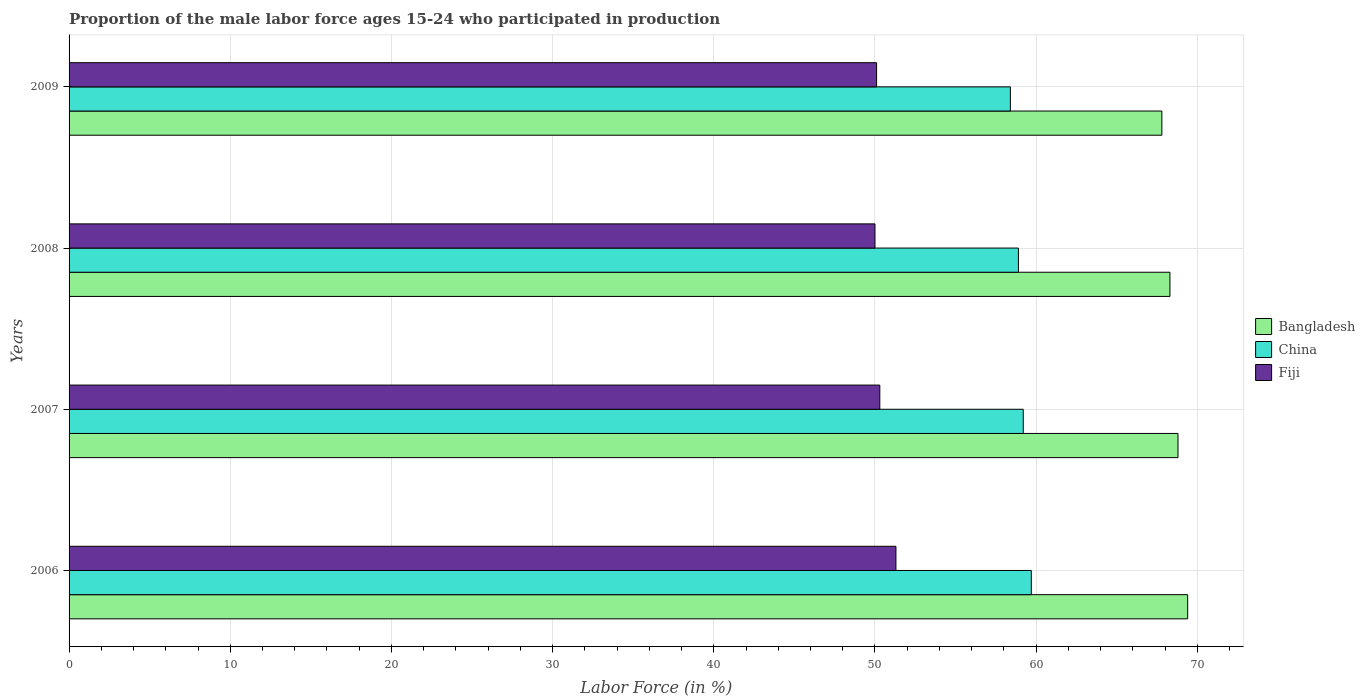How many groups of bars are there?
Provide a succinct answer. 4. Are the number of bars on each tick of the Y-axis equal?
Make the answer very short. Yes. How many bars are there on the 3rd tick from the top?
Make the answer very short. 3. How many bars are there on the 3rd tick from the bottom?
Your answer should be compact. 3. What is the label of the 1st group of bars from the top?
Offer a terse response. 2009. What is the proportion of the male labor force who participated in production in Bangladesh in 2008?
Your answer should be compact. 68.3. Across all years, what is the maximum proportion of the male labor force who participated in production in Fiji?
Keep it short and to the point. 51.3. Across all years, what is the minimum proportion of the male labor force who participated in production in China?
Provide a short and direct response. 58.4. In which year was the proportion of the male labor force who participated in production in Fiji minimum?
Your response must be concise. 2008. What is the total proportion of the male labor force who participated in production in Bangladesh in the graph?
Your answer should be compact. 274.3. What is the difference between the proportion of the male labor force who participated in production in Bangladesh in 2006 and the proportion of the male labor force who participated in production in China in 2007?
Your response must be concise. 10.2. What is the average proportion of the male labor force who participated in production in Fiji per year?
Your response must be concise. 50.42. In the year 2006, what is the difference between the proportion of the male labor force who participated in production in China and proportion of the male labor force who participated in production in Bangladesh?
Make the answer very short. -9.7. In how many years, is the proportion of the male labor force who participated in production in China greater than 66 %?
Offer a very short reply. 0. What is the ratio of the proportion of the male labor force who participated in production in China in 2006 to that in 2009?
Give a very brief answer. 1.02. What is the difference between the highest and the second highest proportion of the male labor force who participated in production in Bangladesh?
Offer a very short reply. 0.6. What is the difference between the highest and the lowest proportion of the male labor force who participated in production in Bangladesh?
Your response must be concise. 1.6. Is the sum of the proportion of the male labor force who participated in production in Fiji in 2007 and 2009 greater than the maximum proportion of the male labor force who participated in production in China across all years?
Make the answer very short. Yes. What does the 3rd bar from the bottom in 2009 represents?
Keep it short and to the point. Fiji. Is it the case that in every year, the sum of the proportion of the male labor force who participated in production in China and proportion of the male labor force who participated in production in Fiji is greater than the proportion of the male labor force who participated in production in Bangladesh?
Provide a succinct answer. Yes. How many years are there in the graph?
Offer a very short reply. 4. What is the difference between two consecutive major ticks on the X-axis?
Provide a short and direct response. 10. Does the graph contain grids?
Your answer should be very brief. Yes. Where does the legend appear in the graph?
Your response must be concise. Center right. How many legend labels are there?
Give a very brief answer. 3. What is the title of the graph?
Offer a terse response. Proportion of the male labor force ages 15-24 who participated in production. What is the Labor Force (in %) of Bangladesh in 2006?
Provide a succinct answer. 69.4. What is the Labor Force (in %) of China in 2006?
Ensure brevity in your answer.  59.7. What is the Labor Force (in %) in Fiji in 2006?
Your answer should be compact. 51.3. What is the Labor Force (in %) of Bangladesh in 2007?
Offer a very short reply. 68.8. What is the Labor Force (in %) in China in 2007?
Give a very brief answer. 59.2. What is the Labor Force (in %) of Fiji in 2007?
Offer a very short reply. 50.3. What is the Labor Force (in %) in Bangladesh in 2008?
Offer a very short reply. 68.3. What is the Labor Force (in %) of China in 2008?
Your answer should be very brief. 58.9. What is the Labor Force (in %) in Fiji in 2008?
Offer a very short reply. 50. What is the Labor Force (in %) of Bangladesh in 2009?
Give a very brief answer. 67.8. What is the Labor Force (in %) in China in 2009?
Offer a terse response. 58.4. What is the Labor Force (in %) in Fiji in 2009?
Offer a very short reply. 50.1. Across all years, what is the maximum Labor Force (in %) of Bangladesh?
Provide a short and direct response. 69.4. Across all years, what is the maximum Labor Force (in %) in China?
Provide a short and direct response. 59.7. Across all years, what is the maximum Labor Force (in %) of Fiji?
Ensure brevity in your answer.  51.3. Across all years, what is the minimum Labor Force (in %) in Bangladesh?
Provide a short and direct response. 67.8. Across all years, what is the minimum Labor Force (in %) in China?
Ensure brevity in your answer.  58.4. What is the total Labor Force (in %) of Bangladesh in the graph?
Ensure brevity in your answer.  274.3. What is the total Labor Force (in %) of China in the graph?
Make the answer very short. 236.2. What is the total Labor Force (in %) of Fiji in the graph?
Ensure brevity in your answer.  201.7. What is the difference between the Labor Force (in %) of China in 2006 and that in 2007?
Your response must be concise. 0.5. What is the difference between the Labor Force (in %) in Fiji in 2006 and that in 2008?
Your response must be concise. 1.3. What is the difference between the Labor Force (in %) of China in 2008 and that in 2009?
Your answer should be compact. 0.5. What is the difference between the Labor Force (in %) of Bangladesh in 2006 and the Labor Force (in %) of Fiji in 2007?
Provide a short and direct response. 19.1. What is the difference between the Labor Force (in %) in Bangladesh in 2006 and the Labor Force (in %) in Fiji in 2008?
Provide a short and direct response. 19.4. What is the difference between the Labor Force (in %) in China in 2006 and the Labor Force (in %) in Fiji in 2008?
Ensure brevity in your answer.  9.7. What is the difference between the Labor Force (in %) of Bangladesh in 2006 and the Labor Force (in %) of Fiji in 2009?
Your answer should be compact. 19.3. What is the difference between the Labor Force (in %) of China in 2006 and the Labor Force (in %) of Fiji in 2009?
Your response must be concise. 9.6. What is the difference between the Labor Force (in %) in Bangladesh in 2007 and the Labor Force (in %) in Fiji in 2008?
Your answer should be compact. 18.8. What is the difference between the Labor Force (in %) of China in 2007 and the Labor Force (in %) of Fiji in 2008?
Ensure brevity in your answer.  9.2. What is the difference between the Labor Force (in %) of Bangladesh in 2007 and the Labor Force (in %) of China in 2009?
Provide a succinct answer. 10.4. What is the difference between the Labor Force (in %) in Bangladesh in 2007 and the Labor Force (in %) in Fiji in 2009?
Keep it short and to the point. 18.7. What is the difference between the Labor Force (in %) of China in 2008 and the Labor Force (in %) of Fiji in 2009?
Offer a terse response. 8.8. What is the average Labor Force (in %) of Bangladesh per year?
Offer a terse response. 68.58. What is the average Labor Force (in %) of China per year?
Offer a very short reply. 59.05. What is the average Labor Force (in %) of Fiji per year?
Offer a very short reply. 50.42. In the year 2006, what is the difference between the Labor Force (in %) in Bangladesh and Labor Force (in %) in China?
Keep it short and to the point. 9.7. In the year 2008, what is the difference between the Labor Force (in %) in Bangladesh and Labor Force (in %) in China?
Your response must be concise. 9.4. In the year 2008, what is the difference between the Labor Force (in %) in Bangladesh and Labor Force (in %) in Fiji?
Make the answer very short. 18.3. In the year 2008, what is the difference between the Labor Force (in %) of China and Labor Force (in %) of Fiji?
Your response must be concise. 8.9. In the year 2009, what is the difference between the Labor Force (in %) of China and Labor Force (in %) of Fiji?
Provide a succinct answer. 8.3. What is the ratio of the Labor Force (in %) of Bangladesh in 2006 to that in 2007?
Provide a short and direct response. 1.01. What is the ratio of the Labor Force (in %) of China in 2006 to that in 2007?
Your answer should be compact. 1.01. What is the ratio of the Labor Force (in %) of Fiji in 2006 to that in 2007?
Provide a short and direct response. 1.02. What is the ratio of the Labor Force (in %) of Bangladesh in 2006 to that in 2008?
Provide a succinct answer. 1.02. What is the ratio of the Labor Force (in %) in China in 2006 to that in 2008?
Keep it short and to the point. 1.01. What is the ratio of the Labor Force (in %) in Bangladesh in 2006 to that in 2009?
Your answer should be very brief. 1.02. What is the ratio of the Labor Force (in %) in China in 2006 to that in 2009?
Ensure brevity in your answer.  1.02. What is the ratio of the Labor Force (in %) in Fiji in 2006 to that in 2009?
Provide a succinct answer. 1.02. What is the ratio of the Labor Force (in %) of Bangladesh in 2007 to that in 2008?
Your answer should be very brief. 1.01. What is the ratio of the Labor Force (in %) of China in 2007 to that in 2008?
Make the answer very short. 1.01. What is the ratio of the Labor Force (in %) in Fiji in 2007 to that in 2008?
Offer a very short reply. 1.01. What is the ratio of the Labor Force (in %) of Bangladesh in 2007 to that in 2009?
Keep it short and to the point. 1.01. What is the ratio of the Labor Force (in %) of China in 2007 to that in 2009?
Ensure brevity in your answer.  1.01. What is the ratio of the Labor Force (in %) in Bangladesh in 2008 to that in 2009?
Provide a short and direct response. 1.01. What is the ratio of the Labor Force (in %) of China in 2008 to that in 2009?
Give a very brief answer. 1.01. What is the ratio of the Labor Force (in %) in Fiji in 2008 to that in 2009?
Provide a succinct answer. 1. What is the difference between the highest and the second highest Labor Force (in %) of Fiji?
Your response must be concise. 1. What is the difference between the highest and the lowest Labor Force (in %) in Bangladesh?
Make the answer very short. 1.6. What is the difference between the highest and the lowest Labor Force (in %) in China?
Your response must be concise. 1.3. What is the difference between the highest and the lowest Labor Force (in %) of Fiji?
Offer a very short reply. 1.3. 